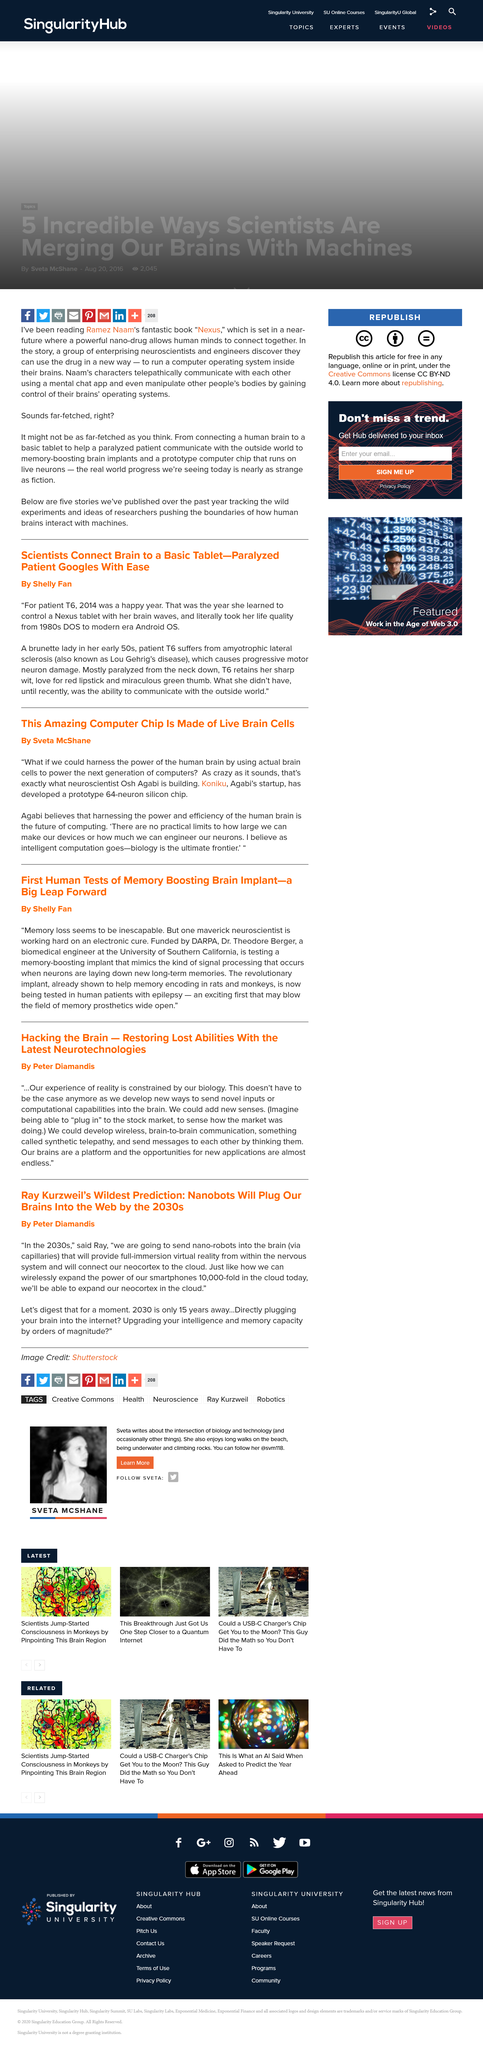Point out several critical features in this image. Amyotrophic lateral sclerosis, also known as Lou Gehrig's disease, is a neurodegenerative disease that affects the nerve cells in the brain and spinal cord that control muscle movement. Osh Agabi's startup is named Koniku. The outcome for patient T6 in 2014 was positive and they experienced happiness. Osh Agabi envisions harnessing the power of the human brain through the utilization of actual brain cells, a bold and innovative approach to unlocking the full potential of our cognitive abilities. The article titled "Scientists Connect Brain to a Basic Tablet - Paralyzed Patient Googles With Ease" was written by Shelly Fan. 